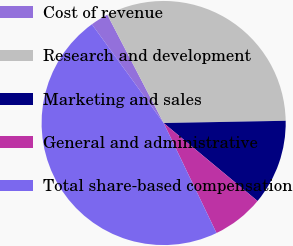<chart> <loc_0><loc_0><loc_500><loc_500><pie_chart><fcel>Cost of revenue<fcel>Research and development<fcel>Marketing and sales<fcel>General and administrative<fcel>Total share-based compensation<nl><fcel>2.37%<fcel>32.34%<fcel>11.32%<fcel>6.84%<fcel>47.13%<nl></chart> 